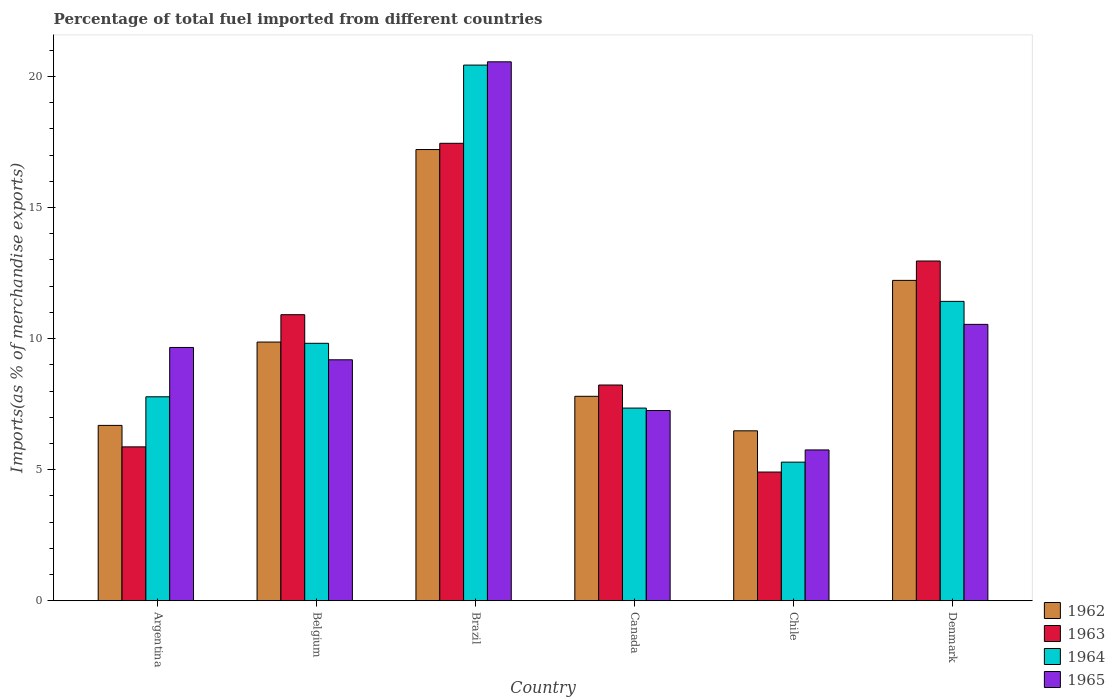How many different coloured bars are there?
Ensure brevity in your answer.  4. How many bars are there on the 4th tick from the left?
Your answer should be very brief. 4. What is the percentage of imports to different countries in 1964 in Canada?
Your answer should be very brief. 7.35. Across all countries, what is the maximum percentage of imports to different countries in 1962?
Your answer should be compact. 17.21. Across all countries, what is the minimum percentage of imports to different countries in 1963?
Make the answer very short. 4.91. In which country was the percentage of imports to different countries in 1962 maximum?
Your response must be concise. Brazil. In which country was the percentage of imports to different countries in 1963 minimum?
Offer a very short reply. Chile. What is the total percentage of imports to different countries in 1965 in the graph?
Offer a very short reply. 62.96. What is the difference between the percentage of imports to different countries in 1964 in Belgium and that in Denmark?
Your answer should be compact. -1.6. What is the difference between the percentage of imports to different countries in 1962 in Canada and the percentage of imports to different countries in 1964 in Argentina?
Your answer should be compact. 0.02. What is the average percentage of imports to different countries in 1962 per country?
Offer a very short reply. 10.04. What is the difference between the percentage of imports to different countries of/in 1962 and percentage of imports to different countries of/in 1965 in Argentina?
Provide a short and direct response. -2.97. In how many countries, is the percentage of imports to different countries in 1962 greater than 8 %?
Your answer should be compact. 3. What is the ratio of the percentage of imports to different countries in 1965 in Canada to that in Chile?
Your response must be concise. 1.26. Is the percentage of imports to different countries in 1963 in Canada less than that in Denmark?
Offer a terse response. Yes. Is the difference between the percentage of imports to different countries in 1962 in Argentina and Canada greater than the difference between the percentage of imports to different countries in 1965 in Argentina and Canada?
Give a very brief answer. No. What is the difference between the highest and the second highest percentage of imports to different countries in 1963?
Ensure brevity in your answer.  6.54. What is the difference between the highest and the lowest percentage of imports to different countries in 1963?
Keep it short and to the point. 12.54. Is it the case that in every country, the sum of the percentage of imports to different countries in 1964 and percentage of imports to different countries in 1963 is greater than the sum of percentage of imports to different countries in 1962 and percentage of imports to different countries in 1965?
Your answer should be compact. No. What does the 3rd bar from the left in Chile represents?
Your response must be concise. 1964. What does the 1st bar from the right in Chile represents?
Provide a succinct answer. 1965. How many bars are there?
Offer a terse response. 24. Are all the bars in the graph horizontal?
Offer a terse response. No. How many countries are there in the graph?
Your answer should be very brief. 6. What is the difference between two consecutive major ticks on the Y-axis?
Your answer should be very brief. 5. Are the values on the major ticks of Y-axis written in scientific E-notation?
Provide a succinct answer. No. Does the graph contain grids?
Offer a very short reply. No. Where does the legend appear in the graph?
Keep it short and to the point. Bottom right. What is the title of the graph?
Offer a very short reply. Percentage of total fuel imported from different countries. Does "1979" appear as one of the legend labels in the graph?
Your answer should be compact. No. What is the label or title of the X-axis?
Your answer should be very brief. Country. What is the label or title of the Y-axis?
Give a very brief answer. Imports(as % of merchandise exports). What is the Imports(as % of merchandise exports) in 1962 in Argentina?
Ensure brevity in your answer.  6.69. What is the Imports(as % of merchandise exports) in 1963 in Argentina?
Give a very brief answer. 5.87. What is the Imports(as % of merchandise exports) of 1964 in Argentina?
Your answer should be very brief. 7.78. What is the Imports(as % of merchandise exports) in 1965 in Argentina?
Keep it short and to the point. 9.66. What is the Imports(as % of merchandise exports) in 1962 in Belgium?
Your answer should be compact. 9.87. What is the Imports(as % of merchandise exports) in 1963 in Belgium?
Make the answer very short. 10.91. What is the Imports(as % of merchandise exports) in 1964 in Belgium?
Your response must be concise. 9.82. What is the Imports(as % of merchandise exports) of 1965 in Belgium?
Your answer should be very brief. 9.19. What is the Imports(as % of merchandise exports) of 1962 in Brazil?
Your answer should be very brief. 17.21. What is the Imports(as % of merchandise exports) of 1963 in Brazil?
Offer a terse response. 17.45. What is the Imports(as % of merchandise exports) in 1964 in Brazil?
Keep it short and to the point. 20.43. What is the Imports(as % of merchandise exports) in 1965 in Brazil?
Keep it short and to the point. 20.55. What is the Imports(as % of merchandise exports) in 1962 in Canada?
Make the answer very short. 7.8. What is the Imports(as % of merchandise exports) in 1963 in Canada?
Your answer should be compact. 8.23. What is the Imports(as % of merchandise exports) in 1964 in Canada?
Make the answer very short. 7.35. What is the Imports(as % of merchandise exports) of 1965 in Canada?
Offer a terse response. 7.26. What is the Imports(as % of merchandise exports) in 1962 in Chile?
Ensure brevity in your answer.  6.48. What is the Imports(as % of merchandise exports) of 1963 in Chile?
Your answer should be very brief. 4.91. What is the Imports(as % of merchandise exports) in 1964 in Chile?
Your answer should be very brief. 5.29. What is the Imports(as % of merchandise exports) in 1965 in Chile?
Your answer should be very brief. 5.75. What is the Imports(as % of merchandise exports) in 1962 in Denmark?
Your answer should be very brief. 12.22. What is the Imports(as % of merchandise exports) of 1963 in Denmark?
Your answer should be compact. 12.96. What is the Imports(as % of merchandise exports) in 1964 in Denmark?
Keep it short and to the point. 11.42. What is the Imports(as % of merchandise exports) in 1965 in Denmark?
Offer a very short reply. 10.54. Across all countries, what is the maximum Imports(as % of merchandise exports) in 1962?
Offer a terse response. 17.21. Across all countries, what is the maximum Imports(as % of merchandise exports) of 1963?
Offer a very short reply. 17.45. Across all countries, what is the maximum Imports(as % of merchandise exports) of 1964?
Make the answer very short. 20.43. Across all countries, what is the maximum Imports(as % of merchandise exports) of 1965?
Offer a terse response. 20.55. Across all countries, what is the minimum Imports(as % of merchandise exports) of 1962?
Your response must be concise. 6.48. Across all countries, what is the minimum Imports(as % of merchandise exports) of 1963?
Ensure brevity in your answer.  4.91. Across all countries, what is the minimum Imports(as % of merchandise exports) in 1964?
Offer a very short reply. 5.29. Across all countries, what is the minimum Imports(as % of merchandise exports) of 1965?
Give a very brief answer. 5.75. What is the total Imports(as % of merchandise exports) of 1962 in the graph?
Offer a terse response. 60.26. What is the total Imports(as % of merchandise exports) in 1963 in the graph?
Offer a terse response. 60.32. What is the total Imports(as % of merchandise exports) in 1964 in the graph?
Your answer should be compact. 62.08. What is the total Imports(as % of merchandise exports) in 1965 in the graph?
Offer a terse response. 62.96. What is the difference between the Imports(as % of merchandise exports) of 1962 in Argentina and that in Belgium?
Offer a terse response. -3.18. What is the difference between the Imports(as % of merchandise exports) in 1963 in Argentina and that in Belgium?
Offer a very short reply. -5.04. What is the difference between the Imports(as % of merchandise exports) of 1964 in Argentina and that in Belgium?
Make the answer very short. -2.04. What is the difference between the Imports(as % of merchandise exports) of 1965 in Argentina and that in Belgium?
Make the answer very short. 0.47. What is the difference between the Imports(as % of merchandise exports) of 1962 in Argentina and that in Brazil?
Ensure brevity in your answer.  -10.52. What is the difference between the Imports(as % of merchandise exports) in 1963 in Argentina and that in Brazil?
Your response must be concise. -11.58. What is the difference between the Imports(as % of merchandise exports) in 1964 in Argentina and that in Brazil?
Give a very brief answer. -12.65. What is the difference between the Imports(as % of merchandise exports) in 1965 in Argentina and that in Brazil?
Keep it short and to the point. -10.89. What is the difference between the Imports(as % of merchandise exports) in 1962 in Argentina and that in Canada?
Provide a short and direct response. -1.11. What is the difference between the Imports(as % of merchandise exports) of 1963 in Argentina and that in Canada?
Your response must be concise. -2.36. What is the difference between the Imports(as % of merchandise exports) of 1964 in Argentina and that in Canada?
Offer a very short reply. 0.43. What is the difference between the Imports(as % of merchandise exports) of 1965 in Argentina and that in Canada?
Make the answer very short. 2.4. What is the difference between the Imports(as % of merchandise exports) in 1962 in Argentina and that in Chile?
Your answer should be very brief. 0.21. What is the difference between the Imports(as % of merchandise exports) in 1964 in Argentina and that in Chile?
Your response must be concise. 2.49. What is the difference between the Imports(as % of merchandise exports) in 1965 in Argentina and that in Chile?
Your answer should be very brief. 3.91. What is the difference between the Imports(as % of merchandise exports) in 1962 in Argentina and that in Denmark?
Your answer should be compact. -5.53. What is the difference between the Imports(as % of merchandise exports) of 1963 in Argentina and that in Denmark?
Provide a short and direct response. -7.09. What is the difference between the Imports(as % of merchandise exports) in 1964 in Argentina and that in Denmark?
Ensure brevity in your answer.  -3.64. What is the difference between the Imports(as % of merchandise exports) in 1965 in Argentina and that in Denmark?
Make the answer very short. -0.88. What is the difference between the Imports(as % of merchandise exports) of 1962 in Belgium and that in Brazil?
Provide a short and direct response. -7.34. What is the difference between the Imports(as % of merchandise exports) in 1963 in Belgium and that in Brazil?
Ensure brevity in your answer.  -6.54. What is the difference between the Imports(as % of merchandise exports) in 1964 in Belgium and that in Brazil?
Provide a succinct answer. -10.61. What is the difference between the Imports(as % of merchandise exports) of 1965 in Belgium and that in Brazil?
Give a very brief answer. -11.36. What is the difference between the Imports(as % of merchandise exports) of 1962 in Belgium and that in Canada?
Provide a succinct answer. 2.07. What is the difference between the Imports(as % of merchandise exports) in 1963 in Belgium and that in Canada?
Your response must be concise. 2.68. What is the difference between the Imports(as % of merchandise exports) of 1964 in Belgium and that in Canada?
Offer a terse response. 2.47. What is the difference between the Imports(as % of merchandise exports) of 1965 in Belgium and that in Canada?
Ensure brevity in your answer.  1.93. What is the difference between the Imports(as % of merchandise exports) in 1962 in Belgium and that in Chile?
Your answer should be very brief. 3.39. What is the difference between the Imports(as % of merchandise exports) in 1963 in Belgium and that in Chile?
Keep it short and to the point. 6. What is the difference between the Imports(as % of merchandise exports) in 1964 in Belgium and that in Chile?
Make the answer very short. 4.53. What is the difference between the Imports(as % of merchandise exports) of 1965 in Belgium and that in Chile?
Provide a short and direct response. 3.44. What is the difference between the Imports(as % of merchandise exports) of 1962 in Belgium and that in Denmark?
Offer a terse response. -2.35. What is the difference between the Imports(as % of merchandise exports) in 1963 in Belgium and that in Denmark?
Keep it short and to the point. -2.05. What is the difference between the Imports(as % of merchandise exports) in 1964 in Belgium and that in Denmark?
Your answer should be very brief. -1.6. What is the difference between the Imports(as % of merchandise exports) of 1965 in Belgium and that in Denmark?
Keep it short and to the point. -1.35. What is the difference between the Imports(as % of merchandise exports) of 1962 in Brazil and that in Canada?
Offer a very short reply. 9.41. What is the difference between the Imports(as % of merchandise exports) in 1963 in Brazil and that in Canada?
Offer a very short reply. 9.22. What is the difference between the Imports(as % of merchandise exports) in 1964 in Brazil and that in Canada?
Ensure brevity in your answer.  13.08. What is the difference between the Imports(as % of merchandise exports) of 1965 in Brazil and that in Canada?
Ensure brevity in your answer.  13.3. What is the difference between the Imports(as % of merchandise exports) of 1962 in Brazil and that in Chile?
Your answer should be very brief. 10.73. What is the difference between the Imports(as % of merchandise exports) of 1963 in Brazil and that in Chile?
Provide a short and direct response. 12.54. What is the difference between the Imports(as % of merchandise exports) of 1964 in Brazil and that in Chile?
Give a very brief answer. 15.14. What is the difference between the Imports(as % of merchandise exports) of 1965 in Brazil and that in Chile?
Your response must be concise. 14.8. What is the difference between the Imports(as % of merchandise exports) in 1962 in Brazil and that in Denmark?
Provide a short and direct response. 4.99. What is the difference between the Imports(as % of merchandise exports) in 1963 in Brazil and that in Denmark?
Provide a succinct answer. 4.49. What is the difference between the Imports(as % of merchandise exports) in 1964 in Brazil and that in Denmark?
Provide a short and direct response. 9.01. What is the difference between the Imports(as % of merchandise exports) of 1965 in Brazil and that in Denmark?
Offer a very short reply. 10.01. What is the difference between the Imports(as % of merchandise exports) of 1962 in Canada and that in Chile?
Make the answer very short. 1.32. What is the difference between the Imports(as % of merchandise exports) of 1963 in Canada and that in Chile?
Your response must be concise. 3.32. What is the difference between the Imports(as % of merchandise exports) of 1964 in Canada and that in Chile?
Your answer should be compact. 2.06. What is the difference between the Imports(as % of merchandise exports) in 1965 in Canada and that in Chile?
Provide a short and direct response. 1.5. What is the difference between the Imports(as % of merchandise exports) of 1962 in Canada and that in Denmark?
Offer a terse response. -4.42. What is the difference between the Imports(as % of merchandise exports) in 1963 in Canada and that in Denmark?
Your answer should be very brief. -4.73. What is the difference between the Imports(as % of merchandise exports) of 1964 in Canada and that in Denmark?
Make the answer very short. -4.07. What is the difference between the Imports(as % of merchandise exports) in 1965 in Canada and that in Denmark?
Give a very brief answer. -3.29. What is the difference between the Imports(as % of merchandise exports) in 1962 in Chile and that in Denmark?
Your answer should be compact. -5.74. What is the difference between the Imports(as % of merchandise exports) in 1963 in Chile and that in Denmark?
Your response must be concise. -8.05. What is the difference between the Imports(as % of merchandise exports) in 1964 in Chile and that in Denmark?
Your answer should be very brief. -6.13. What is the difference between the Imports(as % of merchandise exports) of 1965 in Chile and that in Denmark?
Your response must be concise. -4.79. What is the difference between the Imports(as % of merchandise exports) of 1962 in Argentina and the Imports(as % of merchandise exports) of 1963 in Belgium?
Make the answer very short. -4.22. What is the difference between the Imports(as % of merchandise exports) in 1962 in Argentina and the Imports(as % of merchandise exports) in 1964 in Belgium?
Make the answer very short. -3.13. What is the difference between the Imports(as % of merchandise exports) in 1962 in Argentina and the Imports(as % of merchandise exports) in 1965 in Belgium?
Offer a very short reply. -2.5. What is the difference between the Imports(as % of merchandise exports) in 1963 in Argentina and the Imports(as % of merchandise exports) in 1964 in Belgium?
Ensure brevity in your answer.  -3.95. What is the difference between the Imports(as % of merchandise exports) in 1963 in Argentina and the Imports(as % of merchandise exports) in 1965 in Belgium?
Provide a short and direct response. -3.32. What is the difference between the Imports(as % of merchandise exports) in 1964 in Argentina and the Imports(as % of merchandise exports) in 1965 in Belgium?
Ensure brevity in your answer.  -1.41. What is the difference between the Imports(as % of merchandise exports) of 1962 in Argentina and the Imports(as % of merchandise exports) of 1963 in Brazil?
Ensure brevity in your answer.  -10.76. What is the difference between the Imports(as % of merchandise exports) of 1962 in Argentina and the Imports(as % of merchandise exports) of 1964 in Brazil?
Make the answer very short. -13.74. What is the difference between the Imports(as % of merchandise exports) in 1962 in Argentina and the Imports(as % of merchandise exports) in 1965 in Brazil?
Your answer should be compact. -13.87. What is the difference between the Imports(as % of merchandise exports) of 1963 in Argentina and the Imports(as % of merchandise exports) of 1964 in Brazil?
Your answer should be very brief. -14.56. What is the difference between the Imports(as % of merchandise exports) of 1963 in Argentina and the Imports(as % of merchandise exports) of 1965 in Brazil?
Ensure brevity in your answer.  -14.68. What is the difference between the Imports(as % of merchandise exports) in 1964 in Argentina and the Imports(as % of merchandise exports) in 1965 in Brazil?
Make the answer very short. -12.77. What is the difference between the Imports(as % of merchandise exports) of 1962 in Argentina and the Imports(as % of merchandise exports) of 1963 in Canada?
Your answer should be very brief. -1.54. What is the difference between the Imports(as % of merchandise exports) of 1962 in Argentina and the Imports(as % of merchandise exports) of 1964 in Canada?
Give a very brief answer. -0.66. What is the difference between the Imports(as % of merchandise exports) in 1962 in Argentina and the Imports(as % of merchandise exports) in 1965 in Canada?
Ensure brevity in your answer.  -0.57. What is the difference between the Imports(as % of merchandise exports) of 1963 in Argentina and the Imports(as % of merchandise exports) of 1964 in Canada?
Ensure brevity in your answer.  -1.48. What is the difference between the Imports(as % of merchandise exports) in 1963 in Argentina and the Imports(as % of merchandise exports) in 1965 in Canada?
Offer a very short reply. -1.39. What is the difference between the Imports(as % of merchandise exports) of 1964 in Argentina and the Imports(as % of merchandise exports) of 1965 in Canada?
Ensure brevity in your answer.  0.52. What is the difference between the Imports(as % of merchandise exports) in 1962 in Argentina and the Imports(as % of merchandise exports) in 1963 in Chile?
Your answer should be very brief. 1.78. What is the difference between the Imports(as % of merchandise exports) of 1962 in Argentina and the Imports(as % of merchandise exports) of 1964 in Chile?
Provide a short and direct response. 1.4. What is the difference between the Imports(as % of merchandise exports) in 1962 in Argentina and the Imports(as % of merchandise exports) in 1965 in Chile?
Your response must be concise. 0.94. What is the difference between the Imports(as % of merchandise exports) of 1963 in Argentina and the Imports(as % of merchandise exports) of 1964 in Chile?
Provide a succinct answer. 0.58. What is the difference between the Imports(as % of merchandise exports) of 1963 in Argentina and the Imports(as % of merchandise exports) of 1965 in Chile?
Provide a succinct answer. 0.12. What is the difference between the Imports(as % of merchandise exports) of 1964 in Argentina and the Imports(as % of merchandise exports) of 1965 in Chile?
Your answer should be compact. 2.03. What is the difference between the Imports(as % of merchandise exports) in 1962 in Argentina and the Imports(as % of merchandise exports) in 1963 in Denmark?
Your answer should be compact. -6.27. What is the difference between the Imports(as % of merchandise exports) in 1962 in Argentina and the Imports(as % of merchandise exports) in 1964 in Denmark?
Ensure brevity in your answer.  -4.73. What is the difference between the Imports(as % of merchandise exports) of 1962 in Argentina and the Imports(as % of merchandise exports) of 1965 in Denmark?
Offer a very short reply. -3.85. What is the difference between the Imports(as % of merchandise exports) of 1963 in Argentina and the Imports(as % of merchandise exports) of 1964 in Denmark?
Give a very brief answer. -5.55. What is the difference between the Imports(as % of merchandise exports) of 1963 in Argentina and the Imports(as % of merchandise exports) of 1965 in Denmark?
Keep it short and to the point. -4.67. What is the difference between the Imports(as % of merchandise exports) in 1964 in Argentina and the Imports(as % of merchandise exports) in 1965 in Denmark?
Keep it short and to the point. -2.76. What is the difference between the Imports(as % of merchandise exports) of 1962 in Belgium and the Imports(as % of merchandise exports) of 1963 in Brazil?
Your answer should be compact. -7.58. What is the difference between the Imports(as % of merchandise exports) in 1962 in Belgium and the Imports(as % of merchandise exports) in 1964 in Brazil?
Offer a terse response. -10.56. What is the difference between the Imports(as % of merchandise exports) in 1962 in Belgium and the Imports(as % of merchandise exports) in 1965 in Brazil?
Your response must be concise. -10.69. What is the difference between the Imports(as % of merchandise exports) in 1963 in Belgium and the Imports(as % of merchandise exports) in 1964 in Brazil?
Provide a succinct answer. -9.52. What is the difference between the Imports(as % of merchandise exports) of 1963 in Belgium and the Imports(as % of merchandise exports) of 1965 in Brazil?
Your answer should be compact. -9.64. What is the difference between the Imports(as % of merchandise exports) in 1964 in Belgium and the Imports(as % of merchandise exports) in 1965 in Brazil?
Offer a terse response. -10.74. What is the difference between the Imports(as % of merchandise exports) in 1962 in Belgium and the Imports(as % of merchandise exports) in 1963 in Canada?
Offer a terse response. 1.64. What is the difference between the Imports(as % of merchandise exports) of 1962 in Belgium and the Imports(as % of merchandise exports) of 1964 in Canada?
Keep it short and to the point. 2.52. What is the difference between the Imports(as % of merchandise exports) in 1962 in Belgium and the Imports(as % of merchandise exports) in 1965 in Canada?
Your response must be concise. 2.61. What is the difference between the Imports(as % of merchandise exports) of 1963 in Belgium and the Imports(as % of merchandise exports) of 1964 in Canada?
Provide a succinct answer. 3.56. What is the difference between the Imports(as % of merchandise exports) of 1963 in Belgium and the Imports(as % of merchandise exports) of 1965 in Canada?
Keep it short and to the point. 3.65. What is the difference between the Imports(as % of merchandise exports) in 1964 in Belgium and the Imports(as % of merchandise exports) in 1965 in Canada?
Your response must be concise. 2.56. What is the difference between the Imports(as % of merchandise exports) of 1962 in Belgium and the Imports(as % of merchandise exports) of 1963 in Chile?
Keep it short and to the point. 4.96. What is the difference between the Imports(as % of merchandise exports) of 1962 in Belgium and the Imports(as % of merchandise exports) of 1964 in Chile?
Provide a succinct answer. 4.58. What is the difference between the Imports(as % of merchandise exports) in 1962 in Belgium and the Imports(as % of merchandise exports) in 1965 in Chile?
Your answer should be compact. 4.11. What is the difference between the Imports(as % of merchandise exports) in 1963 in Belgium and the Imports(as % of merchandise exports) in 1964 in Chile?
Your answer should be compact. 5.62. What is the difference between the Imports(as % of merchandise exports) of 1963 in Belgium and the Imports(as % of merchandise exports) of 1965 in Chile?
Provide a succinct answer. 5.16. What is the difference between the Imports(as % of merchandise exports) in 1964 in Belgium and the Imports(as % of merchandise exports) in 1965 in Chile?
Your answer should be compact. 4.07. What is the difference between the Imports(as % of merchandise exports) of 1962 in Belgium and the Imports(as % of merchandise exports) of 1963 in Denmark?
Your response must be concise. -3.09. What is the difference between the Imports(as % of merchandise exports) of 1962 in Belgium and the Imports(as % of merchandise exports) of 1964 in Denmark?
Ensure brevity in your answer.  -1.55. What is the difference between the Imports(as % of merchandise exports) of 1962 in Belgium and the Imports(as % of merchandise exports) of 1965 in Denmark?
Make the answer very short. -0.67. What is the difference between the Imports(as % of merchandise exports) in 1963 in Belgium and the Imports(as % of merchandise exports) in 1964 in Denmark?
Ensure brevity in your answer.  -0.51. What is the difference between the Imports(as % of merchandise exports) in 1963 in Belgium and the Imports(as % of merchandise exports) in 1965 in Denmark?
Offer a very short reply. 0.37. What is the difference between the Imports(as % of merchandise exports) of 1964 in Belgium and the Imports(as % of merchandise exports) of 1965 in Denmark?
Offer a terse response. -0.72. What is the difference between the Imports(as % of merchandise exports) of 1962 in Brazil and the Imports(as % of merchandise exports) of 1963 in Canada?
Offer a very short reply. 8.98. What is the difference between the Imports(as % of merchandise exports) in 1962 in Brazil and the Imports(as % of merchandise exports) in 1964 in Canada?
Offer a very short reply. 9.86. What is the difference between the Imports(as % of merchandise exports) in 1962 in Brazil and the Imports(as % of merchandise exports) in 1965 in Canada?
Offer a terse response. 9.95. What is the difference between the Imports(as % of merchandise exports) in 1963 in Brazil and the Imports(as % of merchandise exports) in 1964 in Canada?
Offer a very short reply. 10.1. What is the difference between the Imports(as % of merchandise exports) in 1963 in Brazil and the Imports(as % of merchandise exports) in 1965 in Canada?
Offer a very short reply. 10.19. What is the difference between the Imports(as % of merchandise exports) in 1964 in Brazil and the Imports(as % of merchandise exports) in 1965 in Canada?
Your answer should be compact. 13.17. What is the difference between the Imports(as % of merchandise exports) in 1962 in Brazil and the Imports(as % of merchandise exports) in 1963 in Chile?
Your response must be concise. 12.3. What is the difference between the Imports(as % of merchandise exports) of 1962 in Brazil and the Imports(as % of merchandise exports) of 1964 in Chile?
Provide a short and direct response. 11.92. What is the difference between the Imports(as % of merchandise exports) of 1962 in Brazil and the Imports(as % of merchandise exports) of 1965 in Chile?
Give a very brief answer. 11.46. What is the difference between the Imports(as % of merchandise exports) of 1963 in Brazil and the Imports(as % of merchandise exports) of 1964 in Chile?
Your response must be concise. 12.16. What is the difference between the Imports(as % of merchandise exports) of 1963 in Brazil and the Imports(as % of merchandise exports) of 1965 in Chile?
Provide a succinct answer. 11.69. What is the difference between the Imports(as % of merchandise exports) in 1964 in Brazil and the Imports(as % of merchandise exports) in 1965 in Chile?
Offer a very short reply. 14.68. What is the difference between the Imports(as % of merchandise exports) of 1962 in Brazil and the Imports(as % of merchandise exports) of 1963 in Denmark?
Your answer should be compact. 4.25. What is the difference between the Imports(as % of merchandise exports) of 1962 in Brazil and the Imports(as % of merchandise exports) of 1964 in Denmark?
Give a very brief answer. 5.79. What is the difference between the Imports(as % of merchandise exports) of 1962 in Brazil and the Imports(as % of merchandise exports) of 1965 in Denmark?
Offer a terse response. 6.67. What is the difference between the Imports(as % of merchandise exports) of 1963 in Brazil and the Imports(as % of merchandise exports) of 1964 in Denmark?
Give a very brief answer. 6.03. What is the difference between the Imports(as % of merchandise exports) of 1963 in Brazil and the Imports(as % of merchandise exports) of 1965 in Denmark?
Give a very brief answer. 6.91. What is the difference between the Imports(as % of merchandise exports) of 1964 in Brazil and the Imports(as % of merchandise exports) of 1965 in Denmark?
Your answer should be very brief. 9.89. What is the difference between the Imports(as % of merchandise exports) in 1962 in Canada and the Imports(as % of merchandise exports) in 1963 in Chile?
Your response must be concise. 2.89. What is the difference between the Imports(as % of merchandise exports) of 1962 in Canada and the Imports(as % of merchandise exports) of 1964 in Chile?
Your answer should be compact. 2.51. What is the difference between the Imports(as % of merchandise exports) of 1962 in Canada and the Imports(as % of merchandise exports) of 1965 in Chile?
Offer a very short reply. 2.04. What is the difference between the Imports(as % of merchandise exports) in 1963 in Canada and the Imports(as % of merchandise exports) in 1964 in Chile?
Make the answer very short. 2.94. What is the difference between the Imports(as % of merchandise exports) of 1963 in Canada and the Imports(as % of merchandise exports) of 1965 in Chile?
Your answer should be compact. 2.48. What is the difference between the Imports(as % of merchandise exports) in 1964 in Canada and the Imports(as % of merchandise exports) in 1965 in Chile?
Ensure brevity in your answer.  1.6. What is the difference between the Imports(as % of merchandise exports) in 1962 in Canada and the Imports(as % of merchandise exports) in 1963 in Denmark?
Offer a terse response. -5.16. What is the difference between the Imports(as % of merchandise exports) in 1962 in Canada and the Imports(as % of merchandise exports) in 1964 in Denmark?
Ensure brevity in your answer.  -3.62. What is the difference between the Imports(as % of merchandise exports) in 1962 in Canada and the Imports(as % of merchandise exports) in 1965 in Denmark?
Your answer should be very brief. -2.74. What is the difference between the Imports(as % of merchandise exports) of 1963 in Canada and the Imports(as % of merchandise exports) of 1964 in Denmark?
Ensure brevity in your answer.  -3.19. What is the difference between the Imports(as % of merchandise exports) of 1963 in Canada and the Imports(as % of merchandise exports) of 1965 in Denmark?
Your answer should be compact. -2.31. What is the difference between the Imports(as % of merchandise exports) in 1964 in Canada and the Imports(as % of merchandise exports) in 1965 in Denmark?
Provide a short and direct response. -3.19. What is the difference between the Imports(as % of merchandise exports) in 1962 in Chile and the Imports(as % of merchandise exports) in 1963 in Denmark?
Offer a terse response. -6.48. What is the difference between the Imports(as % of merchandise exports) of 1962 in Chile and the Imports(as % of merchandise exports) of 1964 in Denmark?
Keep it short and to the point. -4.94. What is the difference between the Imports(as % of merchandise exports) in 1962 in Chile and the Imports(as % of merchandise exports) in 1965 in Denmark?
Keep it short and to the point. -4.06. What is the difference between the Imports(as % of merchandise exports) in 1963 in Chile and the Imports(as % of merchandise exports) in 1964 in Denmark?
Offer a terse response. -6.51. What is the difference between the Imports(as % of merchandise exports) in 1963 in Chile and the Imports(as % of merchandise exports) in 1965 in Denmark?
Provide a short and direct response. -5.63. What is the difference between the Imports(as % of merchandise exports) in 1964 in Chile and the Imports(as % of merchandise exports) in 1965 in Denmark?
Your answer should be compact. -5.25. What is the average Imports(as % of merchandise exports) of 1962 per country?
Make the answer very short. 10.04. What is the average Imports(as % of merchandise exports) of 1963 per country?
Your answer should be very brief. 10.05. What is the average Imports(as % of merchandise exports) of 1964 per country?
Offer a terse response. 10.35. What is the average Imports(as % of merchandise exports) in 1965 per country?
Ensure brevity in your answer.  10.49. What is the difference between the Imports(as % of merchandise exports) in 1962 and Imports(as % of merchandise exports) in 1963 in Argentina?
Your answer should be compact. 0.82. What is the difference between the Imports(as % of merchandise exports) in 1962 and Imports(as % of merchandise exports) in 1964 in Argentina?
Give a very brief answer. -1.09. What is the difference between the Imports(as % of merchandise exports) in 1962 and Imports(as % of merchandise exports) in 1965 in Argentina?
Your answer should be very brief. -2.97. What is the difference between the Imports(as % of merchandise exports) in 1963 and Imports(as % of merchandise exports) in 1964 in Argentina?
Your answer should be very brief. -1.91. What is the difference between the Imports(as % of merchandise exports) in 1963 and Imports(as % of merchandise exports) in 1965 in Argentina?
Your response must be concise. -3.79. What is the difference between the Imports(as % of merchandise exports) of 1964 and Imports(as % of merchandise exports) of 1965 in Argentina?
Your answer should be compact. -1.88. What is the difference between the Imports(as % of merchandise exports) of 1962 and Imports(as % of merchandise exports) of 1963 in Belgium?
Offer a terse response. -1.04. What is the difference between the Imports(as % of merchandise exports) of 1962 and Imports(as % of merchandise exports) of 1964 in Belgium?
Your response must be concise. 0.05. What is the difference between the Imports(as % of merchandise exports) in 1962 and Imports(as % of merchandise exports) in 1965 in Belgium?
Make the answer very short. 0.68. What is the difference between the Imports(as % of merchandise exports) in 1963 and Imports(as % of merchandise exports) in 1964 in Belgium?
Your answer should be very brief. 1.09. What is the difference between the Imports(as % of merchandise exports) in 1963 and Imports(as % of merchandise exports) in 1965 in Belgium?
Ensure brevity in your answer.  1.72. What is the difference between the Imports(as % of merchandise exports) of 1964 and Imports(as % of merchandise exports) of 1965 in Belgium?
Make the answer very short. 0.63. What is the difference between the Imports(as % of merchandise exports) in 1962 and Imports(as % of merchandise exports) in 1963 in Brazil?
Give a very brief answer. -0.24. What is the difference between the Imports(as % of merchandise exports) in 1962 and Imports(as % of merchandise exports) in 1964 in Brazil?
Provide a succinct answer. -3.22. What is the difference between the Imports(as % of merchandise exports) in 1962 and Imports(as % of merchandise exports) in 1965 in Brazil?
Keep it short and to the point. -3.35. What is the difference between the Imports(as % of merchandise exports) in 1963 and Imports(as % of merchandise exports) in 1964 in Brazil?
Offer a terse response. -2.98. What is the difference between the Imports(as % of merchandise exports) of 1963 and Imports(as % of merchandise exports) of 1965 in Brazil?
Provide a short and direct response. -3.11. What is the difference between the Imports(as % of merchandise exports) of 1964 and Imports(as % of merchandise exports) of 1965 in Brazil?
Make the answer very short. -0.12. What is the difference between the Imports(as % of merchandise exports) of 1962 and Imports(as % of merchandise exports) of 1963 in Canada?
Make the answer very short. -0.43. What is the difference between the Imports(as % of merchandise exports) in 1962 and Imports(as % of merchandise exports) in 1964 in Canada?
Offer a terse response. 0.45. What is the difference between the Imports(as % of merchandise exports) in 1962 and Imports(as % of merchandise exports) in 1965 in Canada?
Provide a succinct answer. 0.54. What is the difference between the Imports(as % of merchandise exports) of 1963 and Imports(as % of merchandise exports) of 1964 in Canada?
Provide a succinct answer. 0.88. What is the difference between the Imports(as % of merchandise exports) in 1963 and Imports(as % of merchandise exports) in 1965 in Canada?
Your response must be concise. 0.97. What is the difference between the Imports(as % of merchandise exports) of 1964 and Imports(as % of merchandise exports) of 1965 in Canada?
Your answer should be compact. 0.09. What is the difference between the Imports(as % of merchandise exports) in 1962 and Imports(as % of merchandise exports) in 1963 in Chile?
Provide a short and direct response. 1.57. What is the difference between the Imports(as % of merchandise exports) in 1962 and Imports(as % of merchandise exports) in 1964 in Chile?
Provide a short and direct response. 1.19. What is the difference between the Imports(as % of merchandise exports) in 1962 and Imports(as % of merchandise exports) in 1965 in Chile?
Ensure brevity in your answer.  0.73. What is the difference between the Imports(as % of merchandise exports) of 1963 and Imports(as % of merchandise exports) of 1964 in Chile?
Give a very brief answer. -0.38. What is the difference between the Imports(as % of merchandise exports) of 1963 and Imports(as % of merchandise exports) of 1965 in Chile?
Your response must be concise. -0.84. What is the difference between the Imports(as % of merchandise exports) of 1964 and Imports(as % of merchandise exports) of 1965 in Chile?
Your answer should be compact. -0.47. What is the difference between the Imports(as % of merchandise exports) of 1962 and Imports(as % of merchandise exports) of 1963 in Denmark?
Keep it short and to the point. -0.74. What is the difference between the Imports(as % of merchandise exports) in 1962 and Imports(as % of merchandise exports) in 1964 in Denmark?
Offer a terse response. 0.8. What is the difference between the Imports(as % of merchandise exports) in 1962 and Imports(as % of merchandise exports) in 1965 in Denmark?
Your answer should be compact. 1.68. What is the difference between the Imports(as % of merchandise exports) in 1963 and Imports(as % of merchandise exports) in 1964 in Denmark?
Ensure brevity in your answer.  1.54. What is the difference between the Imports(as % of merchandise exports) of 1963 and Imports(as % of merchandise exports) of 1965 in Denmark?
Offer a very short reply. 2.42. What is the difference between the Imports(as % of merchandise exports) in 1964 and Imports(as % of merchandise exports) in 1965 in Denmark?
Keep it short and to the point. 0.88. What is the ratio of the Imports(as % of merchandise exports) of 1962 in Argentina to that in Belgium?
Ensure brevity in your answer.  0.68. What is the ratio of the Imports(as % of merchandise exports) in 1963 in Argentina to that in Belgium?
Keep it short and to the point. 0.54. What is the ratio of the Imports(as % of merchandise exports) in 1964 in Argentina to that in Belgium?
Provide a succinct answer. 0.79. What is the ratio of the Imports(as % of merchandise exports) of 1965 in Argentina to that in Belgium?
Provide a succinct answer. 1.05. What is the ratio of the Imports(as % of merchandise exports) of 1962 in Argentina to that in Brazil?
Give a very brief answer. 0.39. What is the ratio of the Imports(as % of merchandise exports) in 1963 in Argentina to that in Brazil?
Offer a very short reply. 0.34. What is the ratio of the Imports(as % of merchandise exports) in 1964 in Argentina to that in Brazil?
Provide a succinct answer. 0.38. What is the ratio of the Imports(as % of merchandise exports) in 1965 in Argentina to that in Brazil?
Your answer should be compact. 0.47. What is the ratio of the Imports(as % of merchandise exports) in 1962 in Argentina to that in Canada?
Your response must be concise. 0.86. What is the ratio of the Imports(as % of merchandise exports) in 1963 in Argentina to that in Canada?
Your answer should be very brief. 0.71. What is the ratio of the Imports(as % of merchandise exports) of 1964 in Argentina to that in Canada?
Keep it short and to the point. 1.06. What is the ratio of the Imports(as % of merchandise exports) of 1965 in Argentina to that in Canada?
Offer a very short reply. 1.33. What is the ratio of the Imports(as % of merchandise exports) of 1962 in Argentina to that in Chile?
Your answer should be very brief. 1.03. What is the ratio of the Imports(as % of merchandise exports) in 1963 in Argentina to that in Chile?
Offer a terse response. 1.2. What is the ratio of the Imports(as % of merchandise exports) of 1964 in Argentina to that in Chile?
Give a very brief answer. 1.47. What is the ratio of the Imports(as % of merchandise exports) of 1965 in Argentina to that in Chile?
Ensure brevity in your answer.  1.68. What is the ratio of the Imports(as % of merchandise exports) in 1962 in Argentina to that in Denmark?
Offer a very short reply. 0.55. What is the ratio of the Imports(as % of merchandise exports) of 1963 in Argentina to that in Denmark?
Provide a succinct answer. 0.45. What is the ratio of the Imports(as % of merchandise exports) of 1964 in Argentina to that in Denmark?
Give a very brief answer. 0.68. What is the ratio of the Imports(as % of merchandise exports) of 1965 in Argentina to that in Denmark?
Provide a short and direct response. 0.92. What is the ratio of the Imports(as % of merchandise exports) of 1962 in Belgium to that in Brazil?
Provide a short and direct response. 0.57. What is the ratio of the Imports(as % of merchandise exports) in 1963 in Belgium to that in Brazil?
Your answer should be compact. 0.63. What is the ratio of the Imports(as % of merchandise exports) of 1964 in Belgium to that in Brazil?
Offer a terse response. 0.48. What is the ratio of the Imports(as % of merchandise exports) of 1965 in Belgium to that in Brazil?
Provide a short and direct response. 0.45. What is the ratio of the Imports(as % of merchandise exports) of 1962 in Belgium to that in Canada?
Give a very brief answer. 1.27. What is the ratio of the Imports(as % of merchandise exports) of 1963 in Belgium to that in Canada?
Provide a succinct answer. 1.33. What is the ratio of the Imports(as % of merchandise exports) of 1964 in Belgium to that in Canada?
Keep it short and to the point. 1.34. What is the ratio of the Imports(as % of merchandise exports) of 1965 in Belgium to that in Canada?
Give a very brief answer. 1.27. What is the ratio of the Imports(as % of merchandise exports) in 1962 in Belgium to that in Chile?
Give a very brief answer. 1.52. What is the ratio of the Imports(as % of merchandise exports) of 1963 in Belgium to that in Chile?
Your answer should be compact. 2.22. What is the ratio of the Imports(as % of merchandise exports) in 1964 in Belgium to that in Chile?
Your response must be concise. 1.86. What is the ratio of the Imports(as % of merchandise exports) of 1965 in Belgium to that in Chile?
Give a very brief answer. 1.6. What is the ratio of the Imports(as % of merchandise exports) of 1962 in Belgium to that in Denmark?
Give a very brief answer. 0.81. What is the ratio of the Imports(as % of merchandise exports) in 1963 in Belgium to that in Denmark?
Provide a short and direct response. 0.84. What is the ratio of the Imports(as % of merchandise exports) of 1964 in Belgium to that in Denmark?
Your response must be concise. 0.86. What is the ratio of the Imports(as % of merchandise exports) in 1965 in Belgium to that in Denmark?
Ensure brevity in your answer.  0.87. What is the ratio of the Imports(as % of merchandise exports) in 1962 in Brazil to that in Canada?
Give a very brief answer. 2.21. What is the ratio of the Imports(as % of merchandise exports) of 1963 in Brazil to that in Canada?
Give a very brief answer. 2.12. What is the ratio of the Imports(as % of merchandise exports) in 1964 in Brazil to that in Canada?
Give a very brief answer. 2.78. What is the ratio of the Imports(as % of merchandise exports) of 1965 in Brazil to that in Canada?
Give a very brief answer. 2.83. What is the ratio of the Imports(as % of merchandise exports) in 1962 in Brazil to that in Chile?
Offer a very short reply. 2.65. What is the ratio of the Imports(as % of merchandise exports) in 1963 in Brazil to that in Chile?
Offer a terse response. 3.55. What is the ratio of the Imports(as % of merchandise exports) in 1964 in Brazil to that in Chile?
Provide a short and direct response. 3.86. What is the ratio of the Imports(as % of merchandise exports) of 1965 in Brazil to that in Chile?
Keep it short and to the point. 3.57. What is the ratio of the Imports(as % of merchandise exports) in 1962 in Brazil to that in Denmark?
Keep it short and to the point. 1.41. What is the ratio of the Imports(as % of merchandise exports) in 1963 in Brazil to that in Denmark?
Offer a very short reply. 1.35. What is the ratio of the Imports(as % of merchandise exports) in 1964 in Brazil to that in Denmark?
Your answer should be very brief. 1.79. What is the ratio of the Imports(as % of merchandise exports) in 1965 in Brazil to that in Denmark?
Keep it short and to the point. 1.95. What is the ratio of the Imports(as % of merchandise exports) of 1962 in Canada to that in Chile?
Make the answer very short. 1.2. What is the ratio of the Imports(as % of merchandise exports) in 1963 in Canada to that in Chile?
Keep it short and to the point. 1.68. What is the ratio of the Imports(as % of merchandise exports) of 1964 in Canada to that in Chile?
Your answer should be compact. 1.39. What is the ratio of the Imports(as % of merchandise exports) of 1965 in Canada to that in Chile?
Offer a very short reply. 1.26. What is the ratio of the Imports(as % of merchandise exports) of 1962 in Canada to that in Denmark?
Make the answer very short. 0.64. What is the ratio of the Imports(as % of merchandise exports) in 1963 in Canada to that in Denmark?
Your response must be concise. 0.64. What is the ratio of the Imports(as % of merchandise exports) of 1964 in Canada to that in Denmark?
Offer a terse response. 0.64. What is the ratio of the Imports(as % of merchandise exports) in 1965 in Canada to that in Denmark?
Offer a terse response. 0.69. What is the ratio of the Imports(as % of merchandise exports) in 1962 in Chile to that in Denmark?
Keep it short and to the point. 0.53. What is the ratio of the Imports(as % of merchandise exports) in 1963 in Chile to that in Denmark?
Offer a very short reply. 0.38. What is the ratio of the Imports(as % of merchandise exports) of 1964 in Chile to that in Denmark?
Your response must be concise. 0.46. What is the ratio of the Imports(as % of merchandise exports) of 1965 in Chile to that in Denmark?
Your answer should be very brief. 0.55. What is the difference between the highest and the second highest Imports(as % of merchandise exports) in 1962?
Provide a succinct answer. 4.99. What is the difference between the highest and the second highest Imports(as % of merchandise exports) in 1963?
Your response must be concise. 4.49. What is the difference between the highest and the second highest Imports(as % of merchandise exports) of 1964?
Provide a short and direct response. 9.01. What is the difference between the highest and the second highest Imports(as % of merchandise exports) in 1965?
Give a very brief answer. 10.01. What is the difference between the highest and the lowest Imports(as % of merchandise exports) in 1962?
Provide a short and direct response. 10.73. What is the difference between the highest and the lowest Imports(as % of merchandise exports) in 1963?
Offer a very short reply. 12.54. What is the difference between the highest and the lowest Imports(as % of merchandise exports) in 1964?
Provide a short and direct response. 15.14. What is the difference between the highest and the lowest Imports(as % of merchandise exports) in 1965?
Offer a terse response. 14.8. 